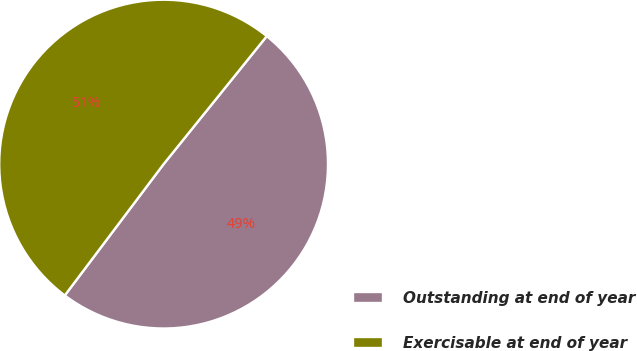<chart> <loc_0><loc_0><loc_500><loc_500><pie_chart><fcel>Outstanding at end of year<fcel>Exercisable at end of year<nl><fcel>49.47%<fcel>50.53%<nl></chart> 